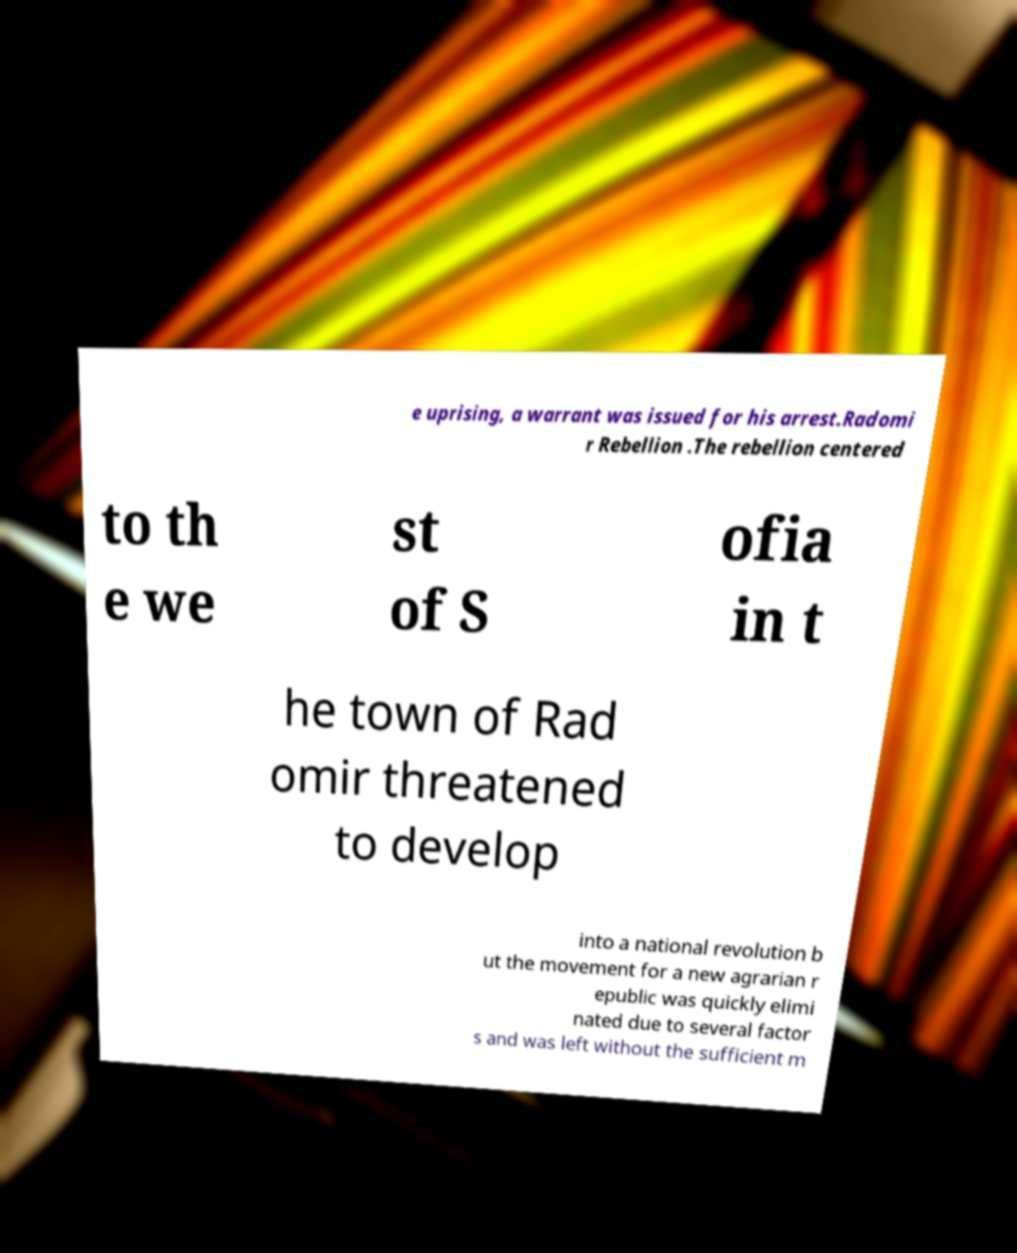Please read and relay the text visible in this image. What does it say? e uprising, a warrant was issued for his arrest.Radomi r Rebellion .The rebellion centered to th e we st of S ofia in t he town of Rad omir threatened to develop into a national revolution b ut the movement for a new agrarian r epublic was quickly elimi nated due to several factor s and was left without the sufficient m 